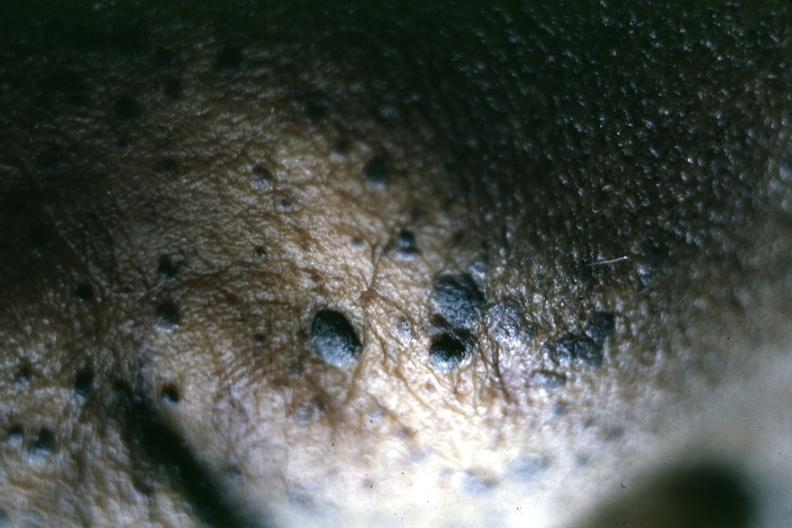what does this image show?
Answer the question using a single word or phrase. Close-up of typical lesions perspective of elevated pasted on lesions is well shown 